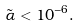Convert formula to latex. <formula><loc_0><loc_0><loc_500><loc_500>\tilde { \alpha } < 1 0 ^ { - 6 } .</formula> 